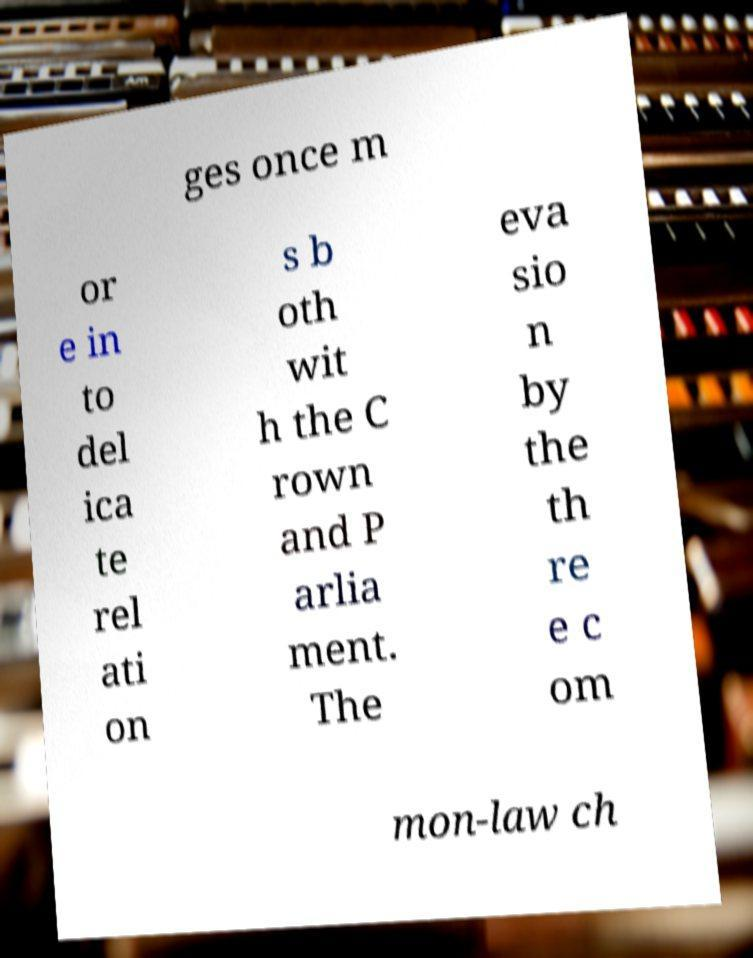Please identify and transcribe the text found in this image. ges once m or e in to del ica te rel ati on s b oth wit h the C rown and P arlia ment. The eva sio n by the th re e c om mon-law ch 